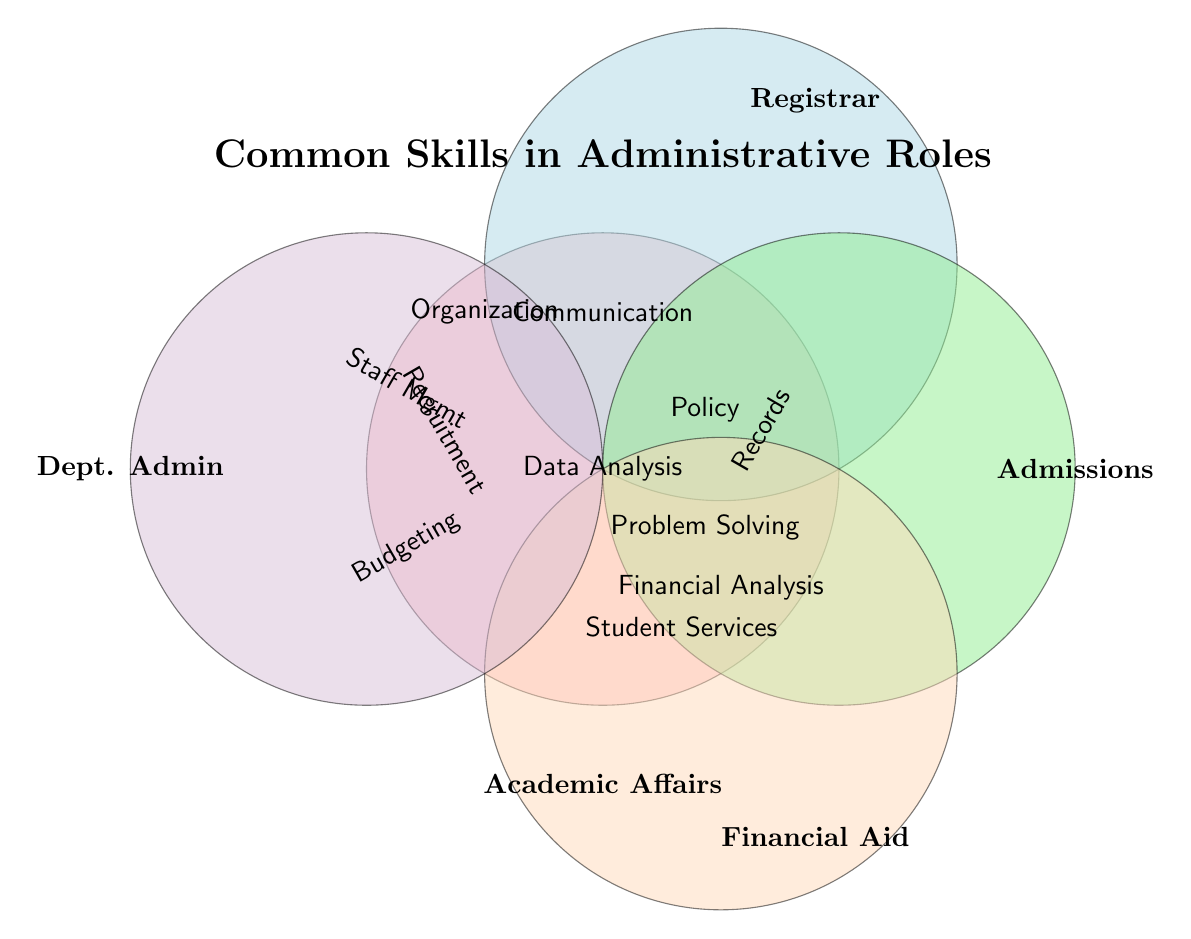What is the title of the Venn Diagram? The title of the Venn Diagram is displayed at the top.
Answer: Common Skills in Administrative Roles Which skills are shared by both Academic Affairs Coordinators and Registrars? To find the shared skills, look at the overlapping area between the circles labeled Academic Affairs Coordinator and Registrar.
Answer: Data Analysis, Policy Knowledge Which role has the unique skill of Records Management? Identify the section labeled with Records Management and see which role it belongs to.
Answer: Registrar How many communication-related roles are there? Find all the roles whose circles overlap with the Communication label. Count the number of these roles.
Answer: Three Which roles share the skill of Student Services? Look at the overlaps around Student Services and identify the roles included.
Answer: Registrar, Admissions Officer, Financial Aid Advisor Do Financial Aid Advisors share any skills with Academic Affairs Coordinators? Look at the overlap between the Financial Aid Advisor circle and the Academic Affairs Coordinator circle.
Answer: No What unique skill does the Admissions Officer have? Identify the skill only present in the Admissions Officer circle with no overlaps with other circles.
Answer: Recruitment Between which roles is the skill of Data Analysis shared? Look at the area labeled Data Analysis which overlaps with multiple circles. Identify those roles.
Answer: Academic Affairs Coordinator, Registrar Which skill do Department Administrators and Financial Aid Advisors share? Look for the overlap between the Department Administrator and Financial Aid Advisor circles.
Answer: They do not share any skills Which roles value Policy Knowledge according to the Venn Diagram? Identify all circles that overlap with the Policy Knowledge area.
Answer: Academic Affairs Coordinator, Registrar, Financial Aid Advisor 